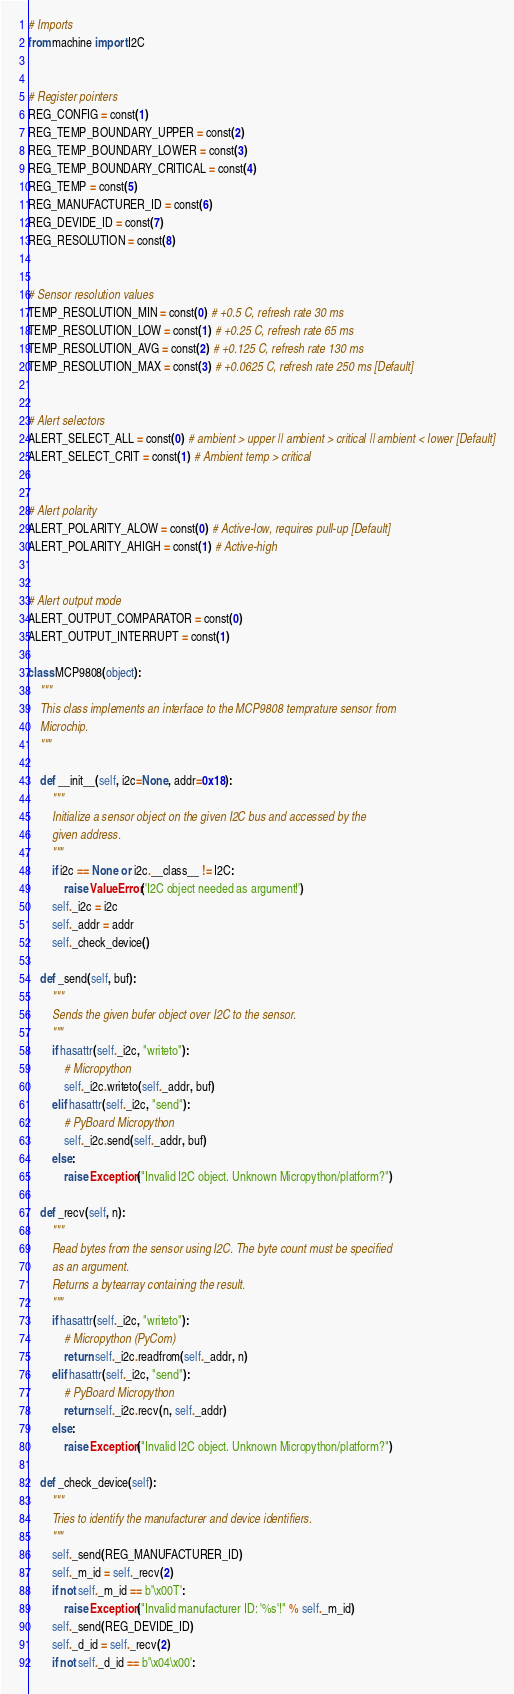<code> <loc_0><loc_0><loc_500><loc_500><_Python_># Imports
from machine import I2C


# Register pointers
REG_CONFIG = const(1)
REG_TEMP_BOUNDARY_UPPER = const(2)
REG_TEMP_BOUNDARY_LOWER = const(3)
REG_TEMP_BOUNDARY_CRITICAL = const(4)
REG_TEMP = const(5)
REG_MANUFACTURER_ID = const(6)
REG_DEVIDE_ID = const(7)
REG_RESOLUTION = const(8)


# Sensor resolution values
TEMP_RESOLUTION_MIN = const(0) # +0.5 C, refresh rate 30 ms
TEMP_RESOLUTION_LOW = const(1) # +0.25 C, refresh rate 65 ms
TEMP_RESOLUTION_AVG = const(2) # +0.125 C, refresh rate 130 ms
TEMP_RESOLUTION_MAX = const(3) # +0.0625 C, refresh rate 250 ms [Default]


# Alert selectors
ALERT_SELECT_ALL = const(0) # ambient > upper || ambient > critical || ambient < lower [Default]
ALERT_SELECT_CRIT = const(1) # Ambient temp > critical


# Alert polarity
ALERT_POLARITY_ALOW = const(0) # Active-low, requires pull-up [Default]
ALERT_POLARITY_AHIGH = const(1) # Active-high


# Alert output mode
ALERT_OUTPUT_COMPARATOR = const(0)
ALERT_OUTPUT_INTERRUPT = const(1)

class MCP9808(object):
    """
    This class implements an interface to the MCP9808 temprature sensor from
    Microchip.
    """

    def __init__(self, i2c=None, addr=0x18):
        """
        Initialize a sensor object on the given I2C bus and accessed by the
        given address.
        """
        if i2c == None or i2c.__class__ != I2C:
            raise ValueError('I2C object needed as argument!')
        self._i2c = i2c
        self._addr = addr
        self._check_device()

    def _send(self, buf):
        """
        Sends the given bufer object over I2C to the sensor.
        """
        if hasattr(self._i2c, "writeto"):
            # Micropython
            self._i2c.writeto(self._addr, buf)
        elif hasattr(self._i2c, "send"):
            # PyBoard Micropython
            self._i2c.send(self._addr, buf)
        else:
            raise Exception("Invalid I2C object. Unknown Micropython/platform?")

    def _recv(self, n):
        """
        Read bytes from the sensor using I2C. The byte count must be specified
        as an argument.
        Returns a bytearray containing the result.
        """
        if hasattr(self._i2c, "writeto"):
            # Micropython (PyCom)
            return self._i2c.readfrom(self._addr, n)
        elif hasattr(self._i2c, "send"):
            # PyBoard Micropython
            return self._i2c.recv(n, self._addr)
        else:
            raise Exception("Invalid I2C object. Unknown Micropython/platform?")

    def _check_device(self):
        """
        Tries to identify the manufacturer and device identifiers.
        """
        self._send(REG_MANUFACTURER_ID)
        self._m_id = self._recv(2)
        if not self._m_id == b'\x00T':
            raise Exception("Invalid manufacturer ID: '%s'!" % self._m_id)
        self._send(REG_DEVIDE_ID)
        self._d_id = self._recv(2)
        if not self._d_id == b'\x04\x00':</code> 